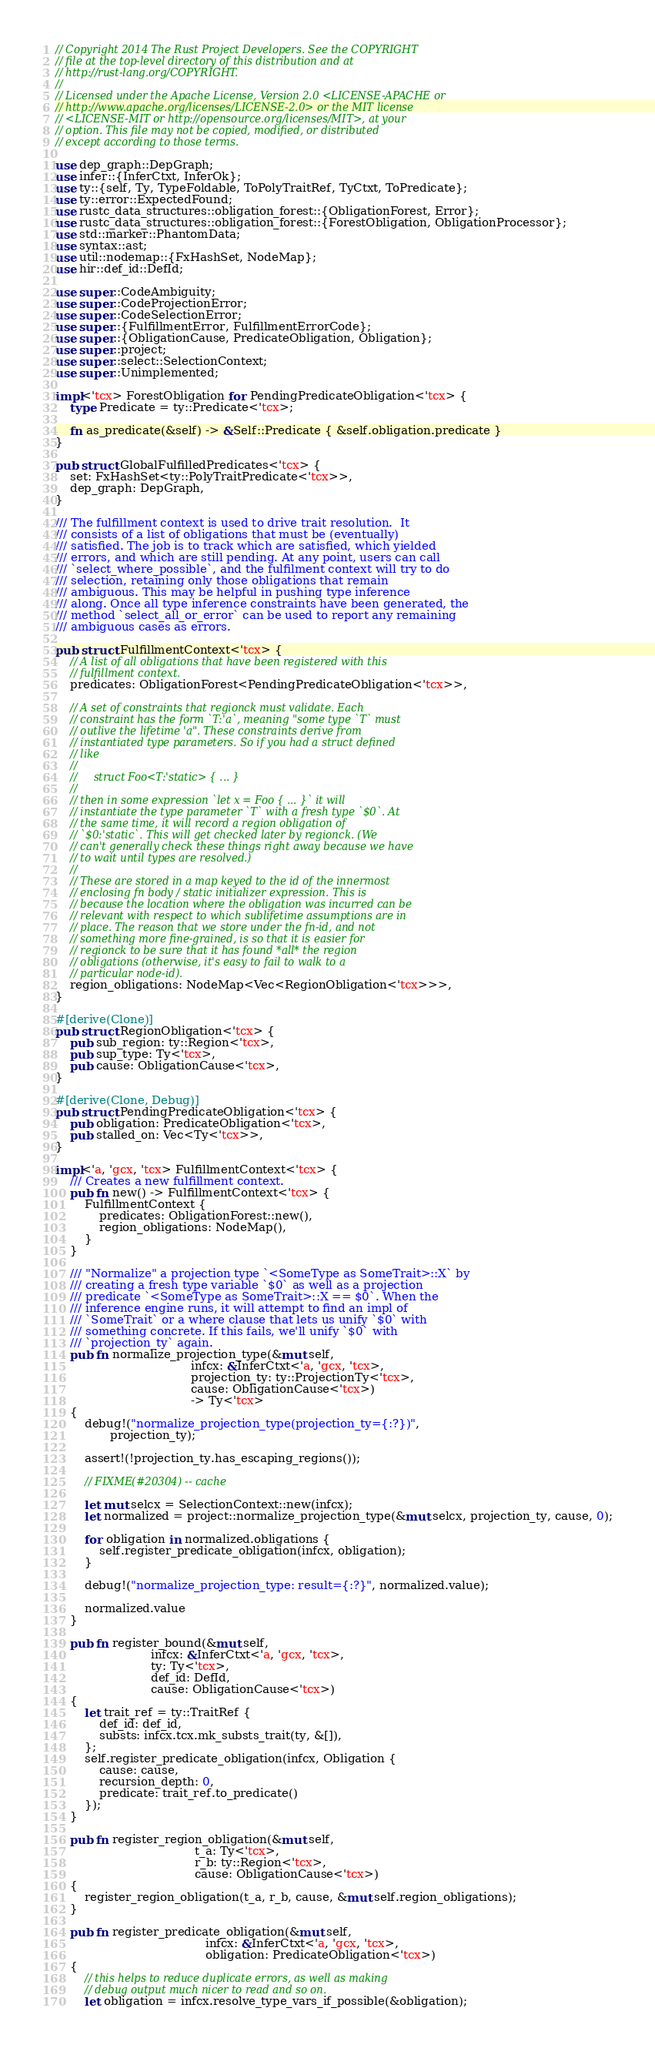<code> <loc_0><loc_0><loc_500><loc_500><_Rust_>// Copyright 2014 The Rust Project Developers. See the COPYRIGHT
// file at the top-level directory of this distribution and at
// http://rust-lang.org/COPYRIGHT.
//
// Licensed under the Apache License, Version 2.0 <LICENSE-APACHE or
// http://www.apache.org/licenses/LICENSE-2.0> or the MIT license
// <LICENSE-MIT or http://opensource.org/licenses/MIT>, at your
// option. This file may not be copied, modified, or distributed
// except according to those terms.

use dep_graph::DepGraph;
use infer::{InferCtxt, InferOk};
use ty::{self, Ty, TypeFoldable, ToPolyTraitRef, TyCtxt, ToPredicate};
use ty::error::ExpectedFound;
use rustc_data_structures::obligation_forest::{ObligationForest, Error};
use rustc_data_structures::obligation_forest::{ForestObligation, ObligationProcessor};
use std::marker::PhantomData;
use syntax::ast;
use util::nodemap::{FxHashSet, NodeMap};
use hir::def_id::DefId;

use super::CodeAmbiguity;
use super::CodeProjectionError;
use super::CodeSelectionError;
use super::{FulfillmentError, FulfillmentErrorCode};
use super::{ObligationCause, PredicateObligation, Obligation};
use super::project;
use super::select::SelectionContext;
use super::Unimplemented;

impl<'tcx> ForestObligation for PendingPredicateObligation<'tcx> {
    type Predicate = ty::Predicate<'tcx>;

    fn as_predicate(&self) -> &Self::Predicate { &self.obligation.predicate }
}

pub struct GlobalFulfilledPredicates<'tcx> {
    set: FxHashSet<ty::PolyTraitPredicate<'tcx>>,
    dep_graph: DepGraph,
}

/// The fulfillment context is used to drive trait resolution.  It
/// consists of a list of obligations that must be (eventually)
/// satisfied. The job is to track which are satisfied, which yielded
/// errors, and which are still pending. At any point, users can call
/// `select_where_possible`, and the fulfilment context will try to do
/// selection, retaining only those obligations that remain
/// ambiguous. This may be helpful in pushing type inference
/// along. Once all type inference constraints have been generated, the
/// method `select_all_or_error` can be used to report any remaining
/// ambiguous cases as errors.

pub struct FulfillmentContext<'tcx> {
    // A list of all obligations that have been registered with this
    // fulfillment context.
    predicates: ObligationForest<PendingPredicateObligation<'tcx>>,

    // A set of constraints that regionck must validate. Each
    // constraint has the form `T:'a`, meaning "some type `T` must
    // outlive the lifetime 'a". These constraints derive from
    // instantiated type parameters. So if you had a struct defined
    // like
    //
    //     struct Foo<T:'static> { ... }
    //
    // then in some expression `let x = Foo { ... }` it will
    // instantiate the type parameter `T` with a fresh type `$0`. At
    // the same time, it will record a region obligation of
    // `$0:'static`. This will get checked later by regionck. (We
    // can't generally check these things right away because we have
    // to wait until types are resolved.)
    //
    // These are stored in a map keyed to the id of the innermost
    // enclosing fn body / static initializer expression. This is
    // because the location where the obligation was incurred can be
    // relevant with respect to which sublifetime assumptions are in
    // place. The reason that we store under the fn-id, and not
    // something more fine-grained, is so that it is easier for
    // regionck to be sure that it has found *all* the region
    // obligations (otherwise, it's easy to fail to walk to a
    // particular node-id).
    region_obligations: NodeMap<Vec<RegionObligation<'tcx>>>,
}

#[derive(Clone)]
pub struct RegionObligation<'tcx> {
    pub sub_region: ty::Region<'tcx>,
    pub sup_type: Ty<'tcx>,
    pub cause: ObligationCause<'tcx>,
}

#[derive(Clone, Debug)]
pub struct PendingPredicateObligation<'tcx> {
    pub obligation: PredicateObligation<'tcx>,
    pub stalled_on: Vec<Ty<'tcx>>,
}

impl<'a, 'gcx, 'tcx> FulfillmentContext<'tcx> {
    /// Creates a new fulfillment context.
    pub fn new() -> FulfillmentContext<'tcx> {
        FulfillmentContext {
            predicates: ObligationForest::new(),
            region_obligations: NodeMap(),
        }
    }

    /// "Normalize" a projection type `<SomeType as SomeTrait>::X` by
    /// creating a fresh type variable `$0` as well as a projection
    /// predicate `<SomeType as SomeTrait>::X == $0`. When the
    /// inference engine runs, it will attempt to find an impl of
    /// `SomeTrait` or a where clause that lets us unify `$0` with
    /// something concrete. If this fails, we'll unify `$0` with
    /// `projection_ty` again.
    pub fn normalize_projection_type(&mut self,
                                     infcx: &InferCtxt<'a, 'gcx, 'tcx>,
                                     projection_ty: ty::ProjectionTy<'tcx>,
                                     cause: ObligationCause<'tcx>)
                                     -> Ty<'tcx>
    {
        debug!("normalize_projection_type(projection_ty={:?})",
               projection_ty);

        assert!(!projection_ty.has_escaping_regions());

        // FIXME(#20304) -- cache

        let mut selcx = SelectionContext::new(infcx);
        let normalized = project::normalize_projection_type(&mut selcx, projection_ty, cause, 0);

        for obligation in normalized.obligations {
            self.register_predicate_obligation(infcx, obligation);
        }

        debug!("normalize_projection_type: result={:?}", normalized.value);

        normalized.value
    }

    pub fn register_bound(&mut self,
                          infcx: &InferCtxt<'a, 'gcx, 'tcx>,
                          ty: Ty<'tcx>,
                          def_id: DefId,
                          cause: ObligationCause<'tcx>)
    {
        let trait_ref = ty::TraitRef {
            def_id: def_id,
            substs: infcx.tcx.mk_substs_trait(ty, &[]),
        };
        self.register_predicate_obligation(infcx, Obligation {
            cause: cause,
            recursion_depth: 0,
            predicate: trait_ref.to_predicate()
        });
    }

    pub fn register_region_obligation(&mut self,
                                      t_a: Ty<'tcx>,
                                      r_b: ty::Region<'tcx>,
                                      cause: ObligationCause<'tcx>)
    {
        register_region_obligation(t_a, r_b, cause, &mut self.region_obligations);
    }

    pub fn register_predicate_obligation(&mut self,
                                         infcx: &InferCtxt<'a, 'gcx, 'tcx>,
                                         obligation: PredicateObligation<'tcx>)
    {
        // this helps to reduce duplicate errors, as well as making
        // debug output much nicer to read and so on.
        let obligation = infcx.resolve_type_vars_if_possible(&obligation);
</code> 